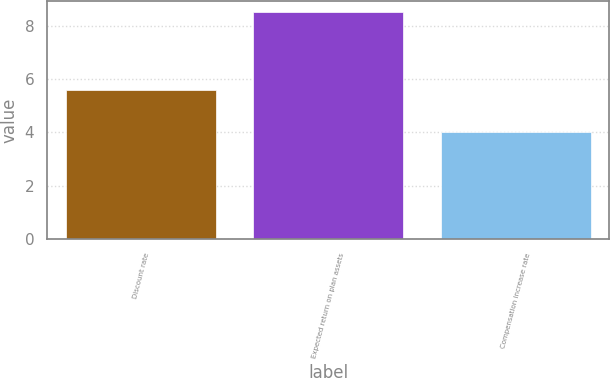Convert chart to OTSL. <chart><loc_0><loc_0><loc_500><loc_500><bar_chart><fcel>Discount rate<fcel>Expected return on plan assets<fcel>Compensation increase rate<nl><fcel>5.6<fcel>8.5<fcel>4<nl></chart> 